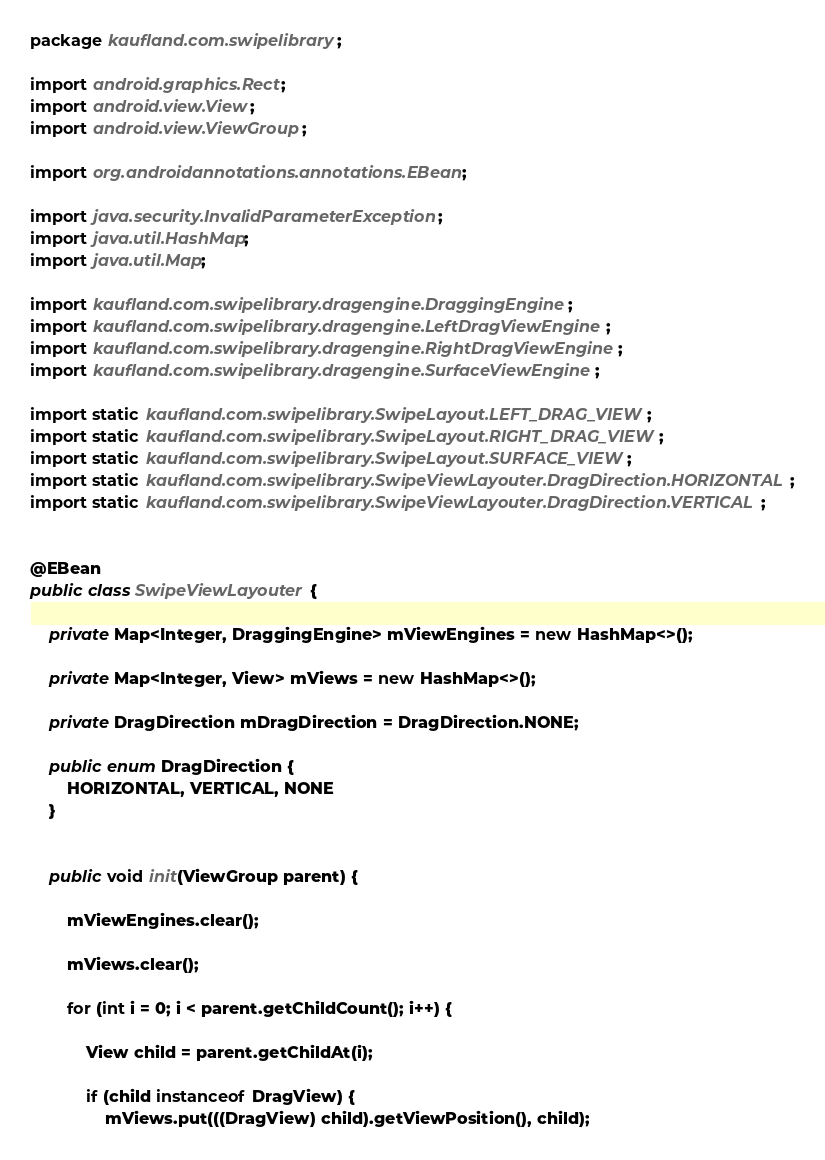Convert code to text. <code><loc_0><loc_0><loc_500><loc_500><_Java_>package kaufland.com.swipelibrary;

import android.graphics.Rect;
import android.view.View;
import android.view.ViewGroup;

import org.androidannotations.annotations.EBean;

import java.security.InvalidParameterException;
import java.util.HashMap;
import java.util.Map;

import kaufland.com.swipelibrary.dragengine.DraggingEngine;
import kaufland.com.swipelibrary.dragengine.LeftDragViewEngine;
import kaufland.com.swipelibrary.dragengine.RightDragViewEngine;
import kaufland.com.swipelibrary.dragengine.SurfaceViewEngine;

import static kaufland.com.swipelibrary.SwipeLayout.LEFT_DRAG_VIEW;
import static kaufland.com.swipelibrary.SwipeLayout.RIGHT_DRAG_VIEW;
import static kaufland.com.swipelibrary.SwipeLayout.SURFACE_VIEW;
import static kaufland.com.swipelibrary.SwipeViewLayouter.DragDirection.HORIZONTAL;
import static kaufland.com.swipelibrary.SwipeViewLayouter.DragDirection.VERTICAL;


@EBean
public class SwipeViewLayouter {

    private Map<Integer, DraggingEngine> mViewEngines = new HashMap<>();

    private Map<Integer, View> mViews = new HashMap<>();

    private DragDirection mDragDirection = DragDirection.NONE;

    public enum DragDirection {
        HORIZONTAL, VERTICAL, NONE
    }


    public void init(ViewGroup parent) {

        mViewEngines.clear();

        mViews.clear();

        for (int i = 0; i < parent.getChildCount(); i++) {

            View child = parent.getChildAt(i);

            if (child instanceof DragView) {
                mViews.put(((DragView) child).getViewPosition(), child);</code> 